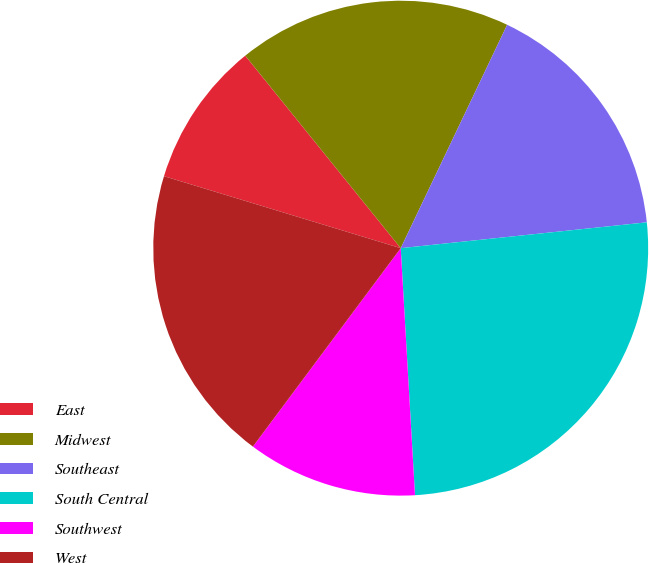<chart> <loc_0><loc_0><loc_500><loc_500><pie_chart><fcel>East<fcel>Midwest<fcel>Southeast<fcel>South Central<fcel>Southwest<fcel>West<nl><fcel>9.49%<fcel>17.89%<fcel>16.26%<fcel>25.75%<fcel>11.11%<fcel>19.51%<nl></chart> 